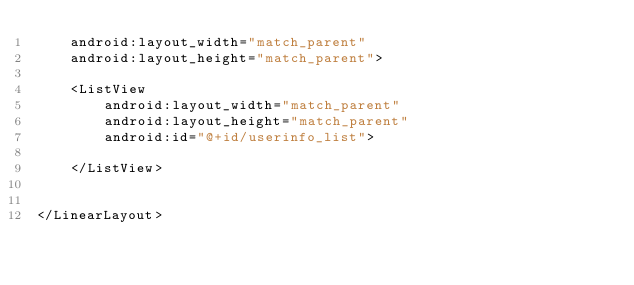Convert code to text. <code><loc_0><loc_0><loc_500><loc_500><_XML_>    android:layout_width="match_parent"
    android:layout_height="match_parent">

    <ListView
        android:layout_width="match_parent"
        android:layout_height="match_parent"
        android:id="@+id/userinfo_list">

    </ListView>


</LinearLayout>
</code> 